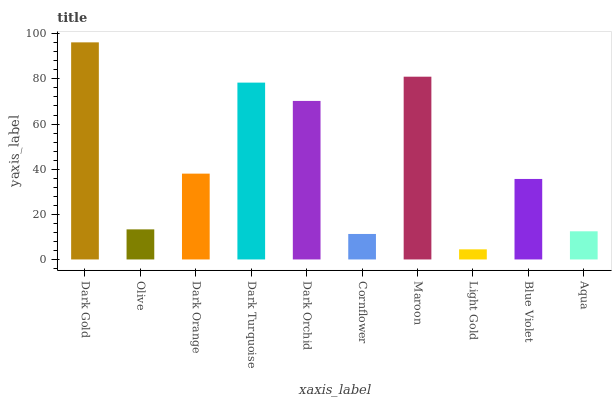Is Light Gold the minimum?
Answer yes or no. Yes. Is Dark Gold the maximum?
Answer yes or no. Yes. Is Olive the minimum?
Answer yes or no. No. Is Olive the maximum?
Answer yes or no. No. Is Dark Gold greater than Olive?
Answer yes or no. Yes. Is Olive less than Dark Gold?
Answer yes or no. Yes. Is Olive greater than Dark Gold?
Answer yes or no. No. Is Dark Gold less than Olive?
Answer yes or no. No. Is Dark Orange the high median?
Answer yes or no. Yes. Is Blue Violet the low median?
Answer yes or no. Yes. Is Olive the high median?
Answer yes or no. No. Is Light Gold the low median?
Answer yes or no. No. 